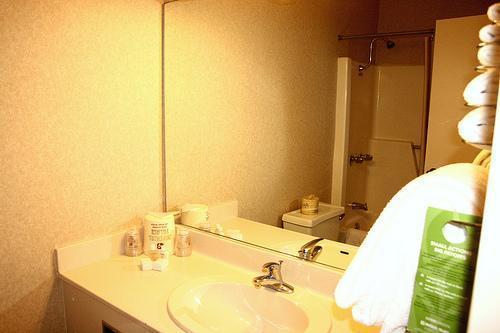How many rolls of toilet paper are on the back of the toilet?
Give a very brief answer. 1. 